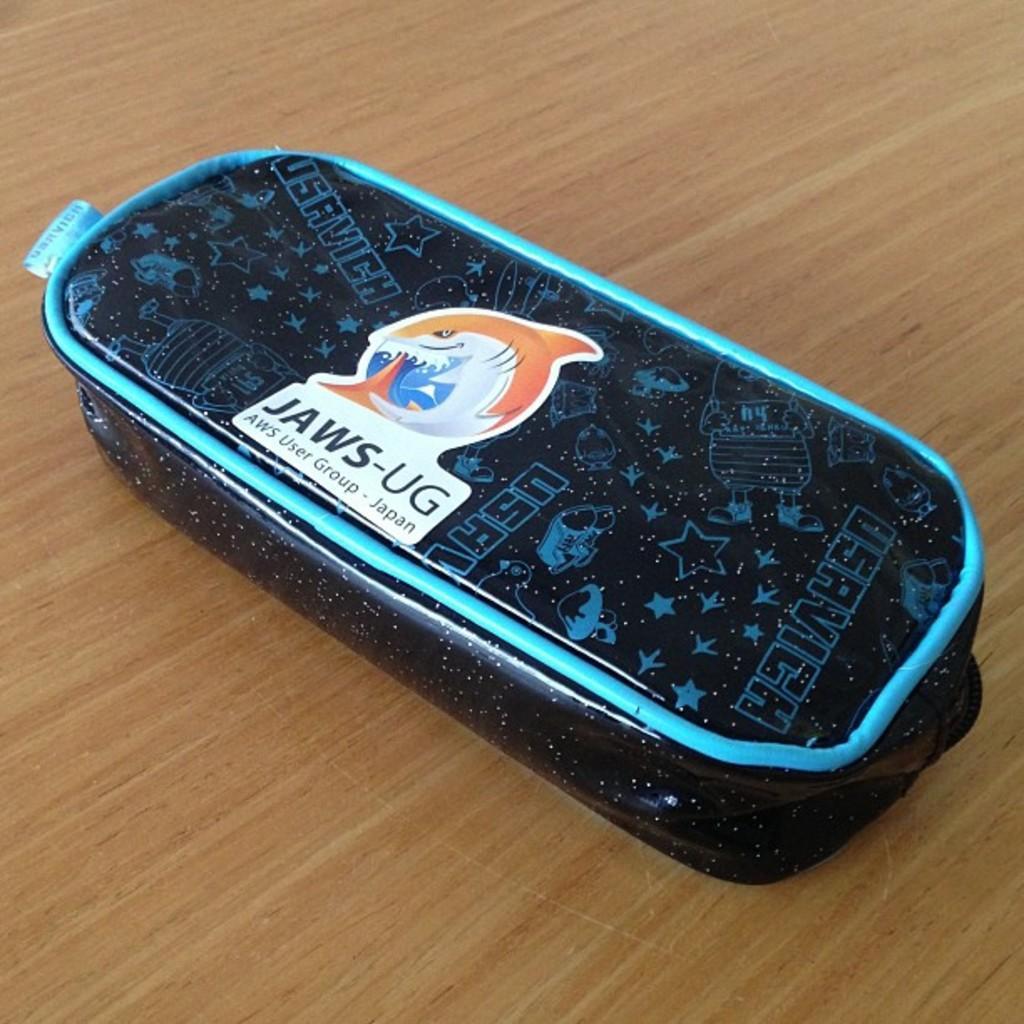Please provide a concise description of this image. In this image we can see a black color object is kept on a wooden floor. 